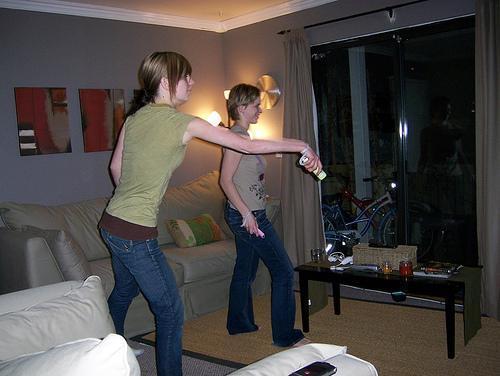How many people are standing?
Give a very brief answer. 2. How many people?
Give a very brief answer. 2. How many couches are in the photo?
Give a very brief answer. 2. How many people are there?
Give a very brief answer. 2. How many cups do you see?
Give a very brief answer. 0. 